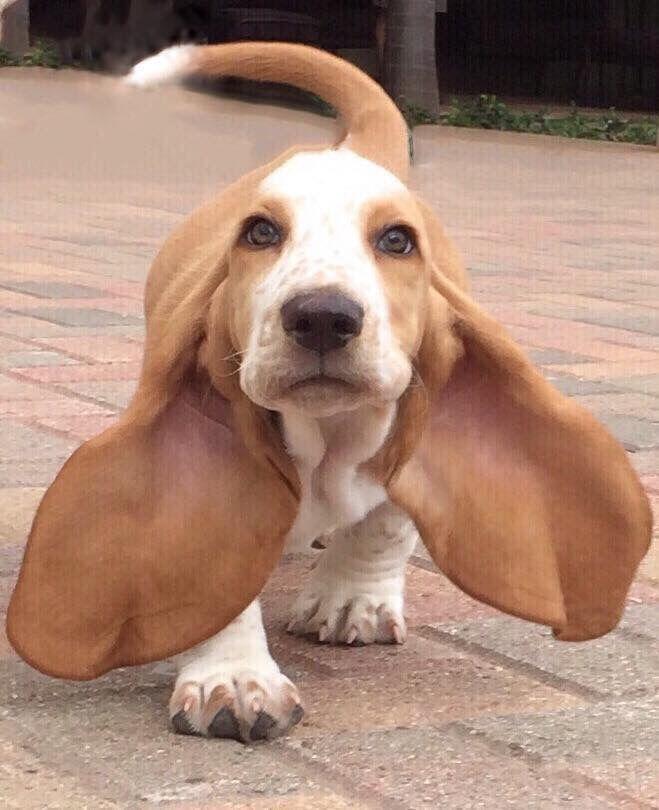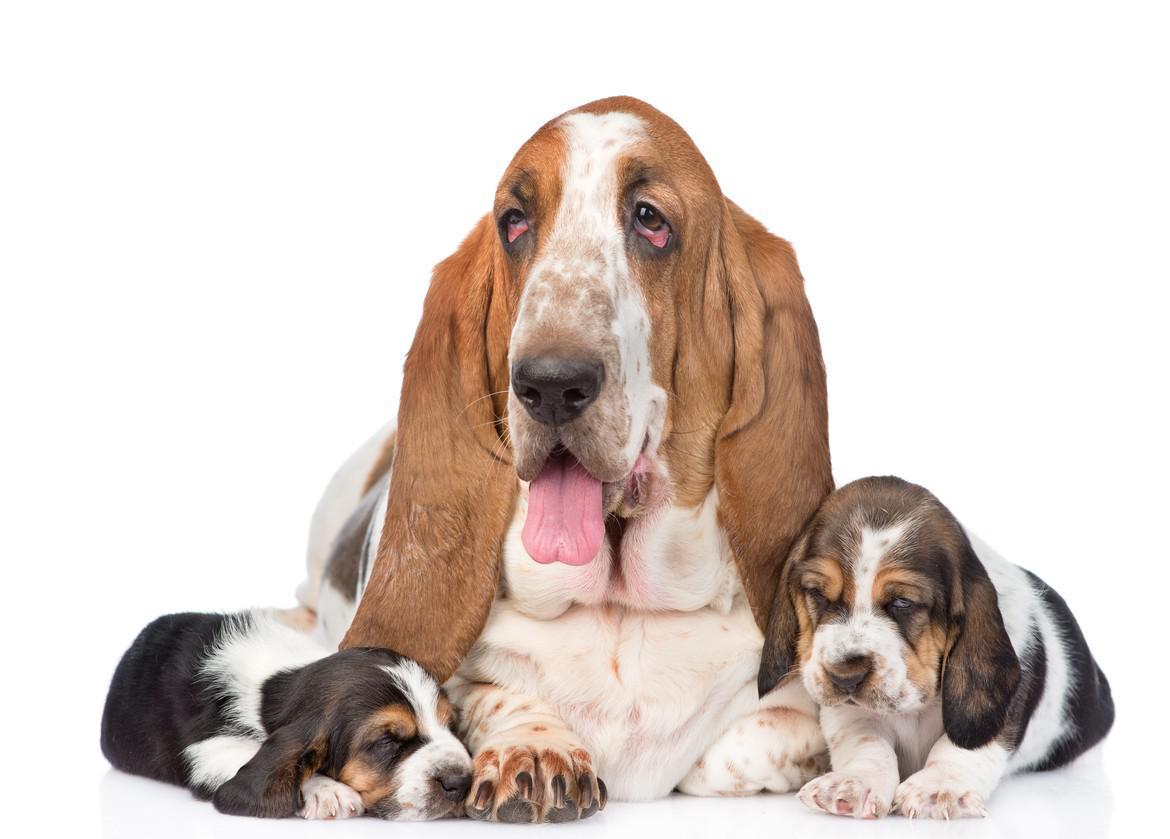The first image is the image on the left, the second image is the image on the right. Assess this claim about the two images: "Both dogs are sitting down.". Correct or not? Answer yes or no. No. The first image is the image on the left, the second image is the image on the right. Analyze the images presented: Is the assertion "There is one basset hound sitting and facing forward and one basset hound facing right and glancing sideways." valid? Answer yes or no. No. 